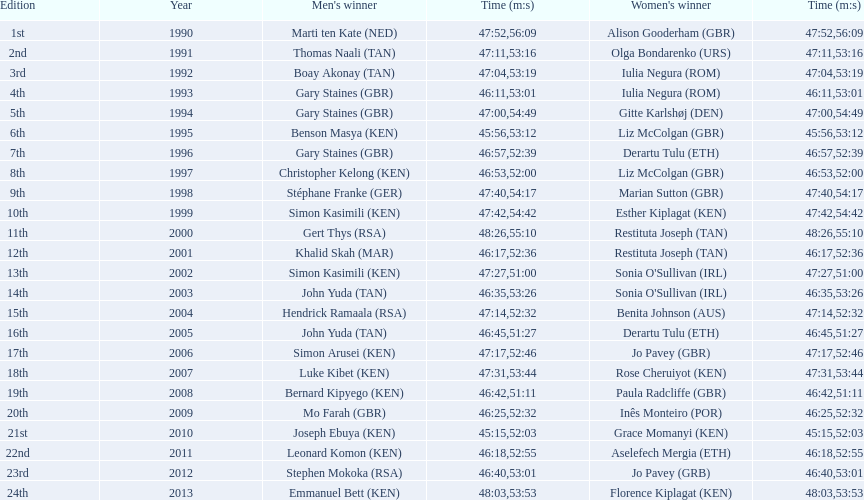Number of men's winners with a finish time under 46:58 12. 